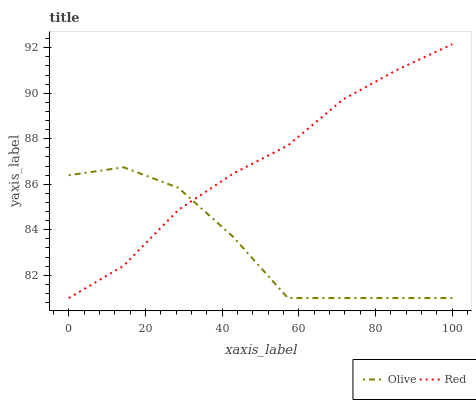Does Olive have the minimum area under the curve?
Answer yes or no. Yes. Does Red have the maximum area under the curve?
Answer yes or no. Yes. Does Red have the minimum area under the curve?
Answer yes or no. No. Is Red the smoothest?
Answer yes or no. Yes. Is Olive the roughest?
Answer yes or no. Yes. Is Red the roughest?
Answer yes or no. No. Does Olive have the lowest value?
Answer yes or no. Yes. Does Red have the highest value?
Answer yes or no. Yes. Does Red intersect Olive?
Answer yes or no. Yes. Is Red less than Olive?
Answer yes or no. No. Is Red greater than Olive?
Answer yes or no. No. 